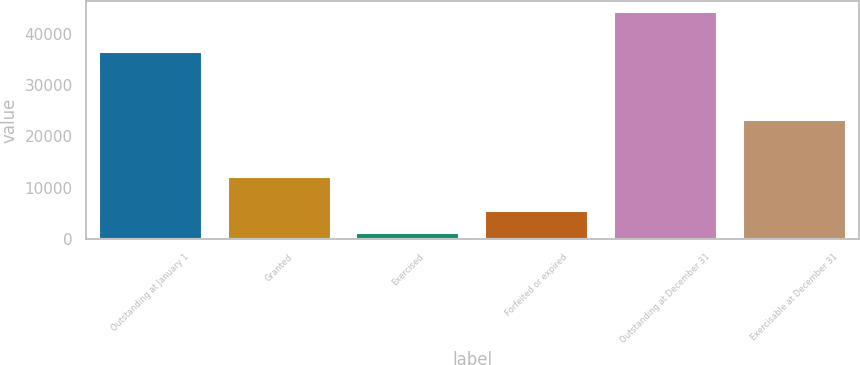Convert chart to OTSL. <chart><loc_0><loc_0><loc_500><loc_500><bar_chart><fcel>Outstanding at January 1<fcel>Granted<fcel>Exercised<fcel>Forfeited or expired<fcel>Outstanding at December 31<fcel>Exercisable at December 31<nl><fcel>36502<fcel>12179<fcel>1271<fcel>5555.9<fcel>44120<fcel>23248<nl></chart> 